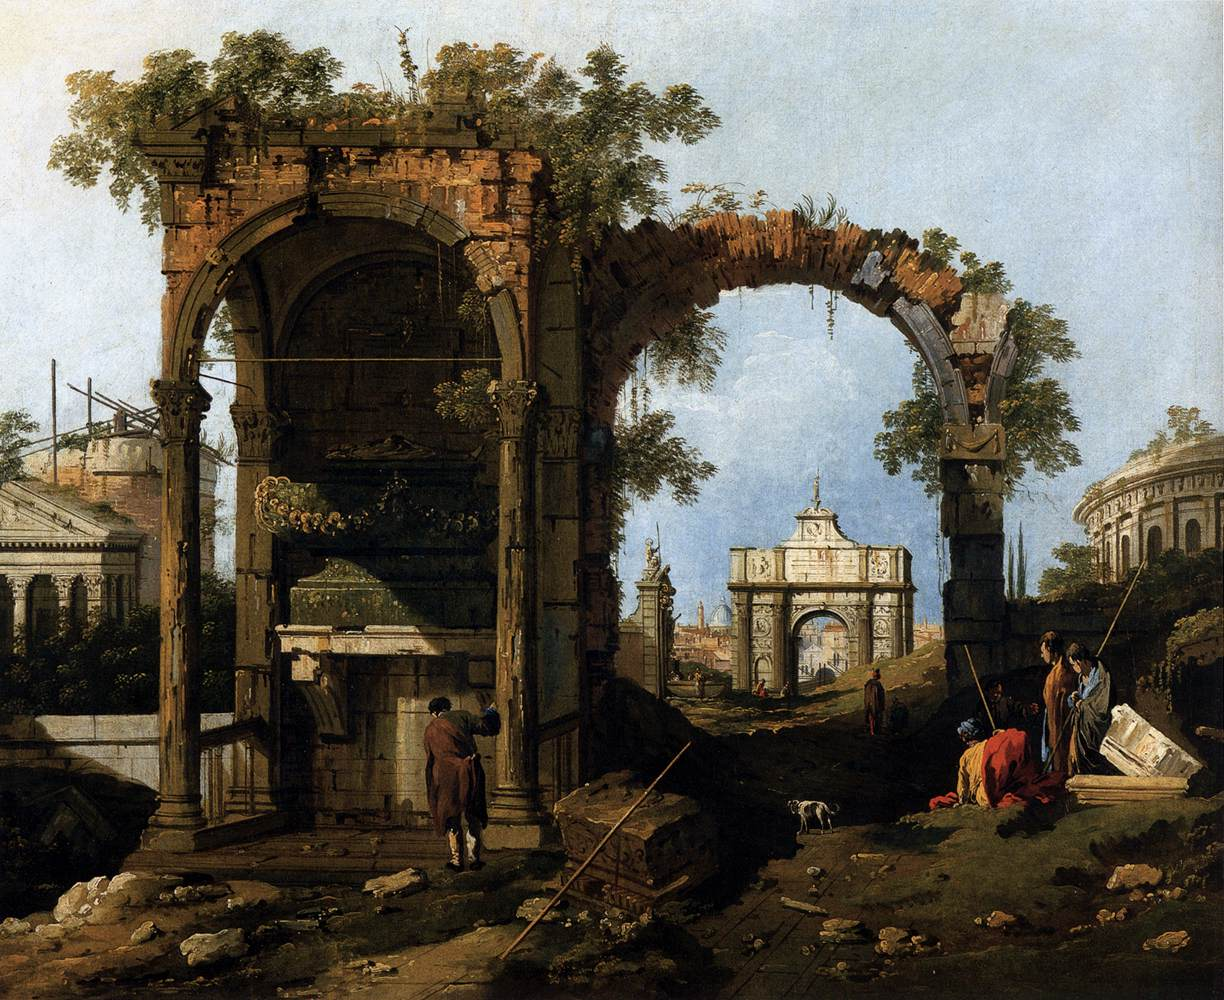What are the key elements in this picture? The image is a mesmerizing oil painting that embodies the essence of the Italian Baroque period. The scene features the ruins of a grand archway with a broken pediment as the focal point. To the right, a smaller archway enhances the composition's depth. Both structures are embraced by verdant foliage, signifying nature's persistence. The foreground is animated by several figures, adding a dynamic human element to the ruins. In the background, a serene blue sky and classical buildings extend the scene, contributing to its sense of scale and magnificence. Earth tones dominate the artist's palette, grounding the scene in realism, while blue and green highlights in the sky and foliage offer a refreshing contrast. This painting is a testament to the artist's skill in capturing the grandeur and drama of a bygone era through meticulous architectural and natural details. 